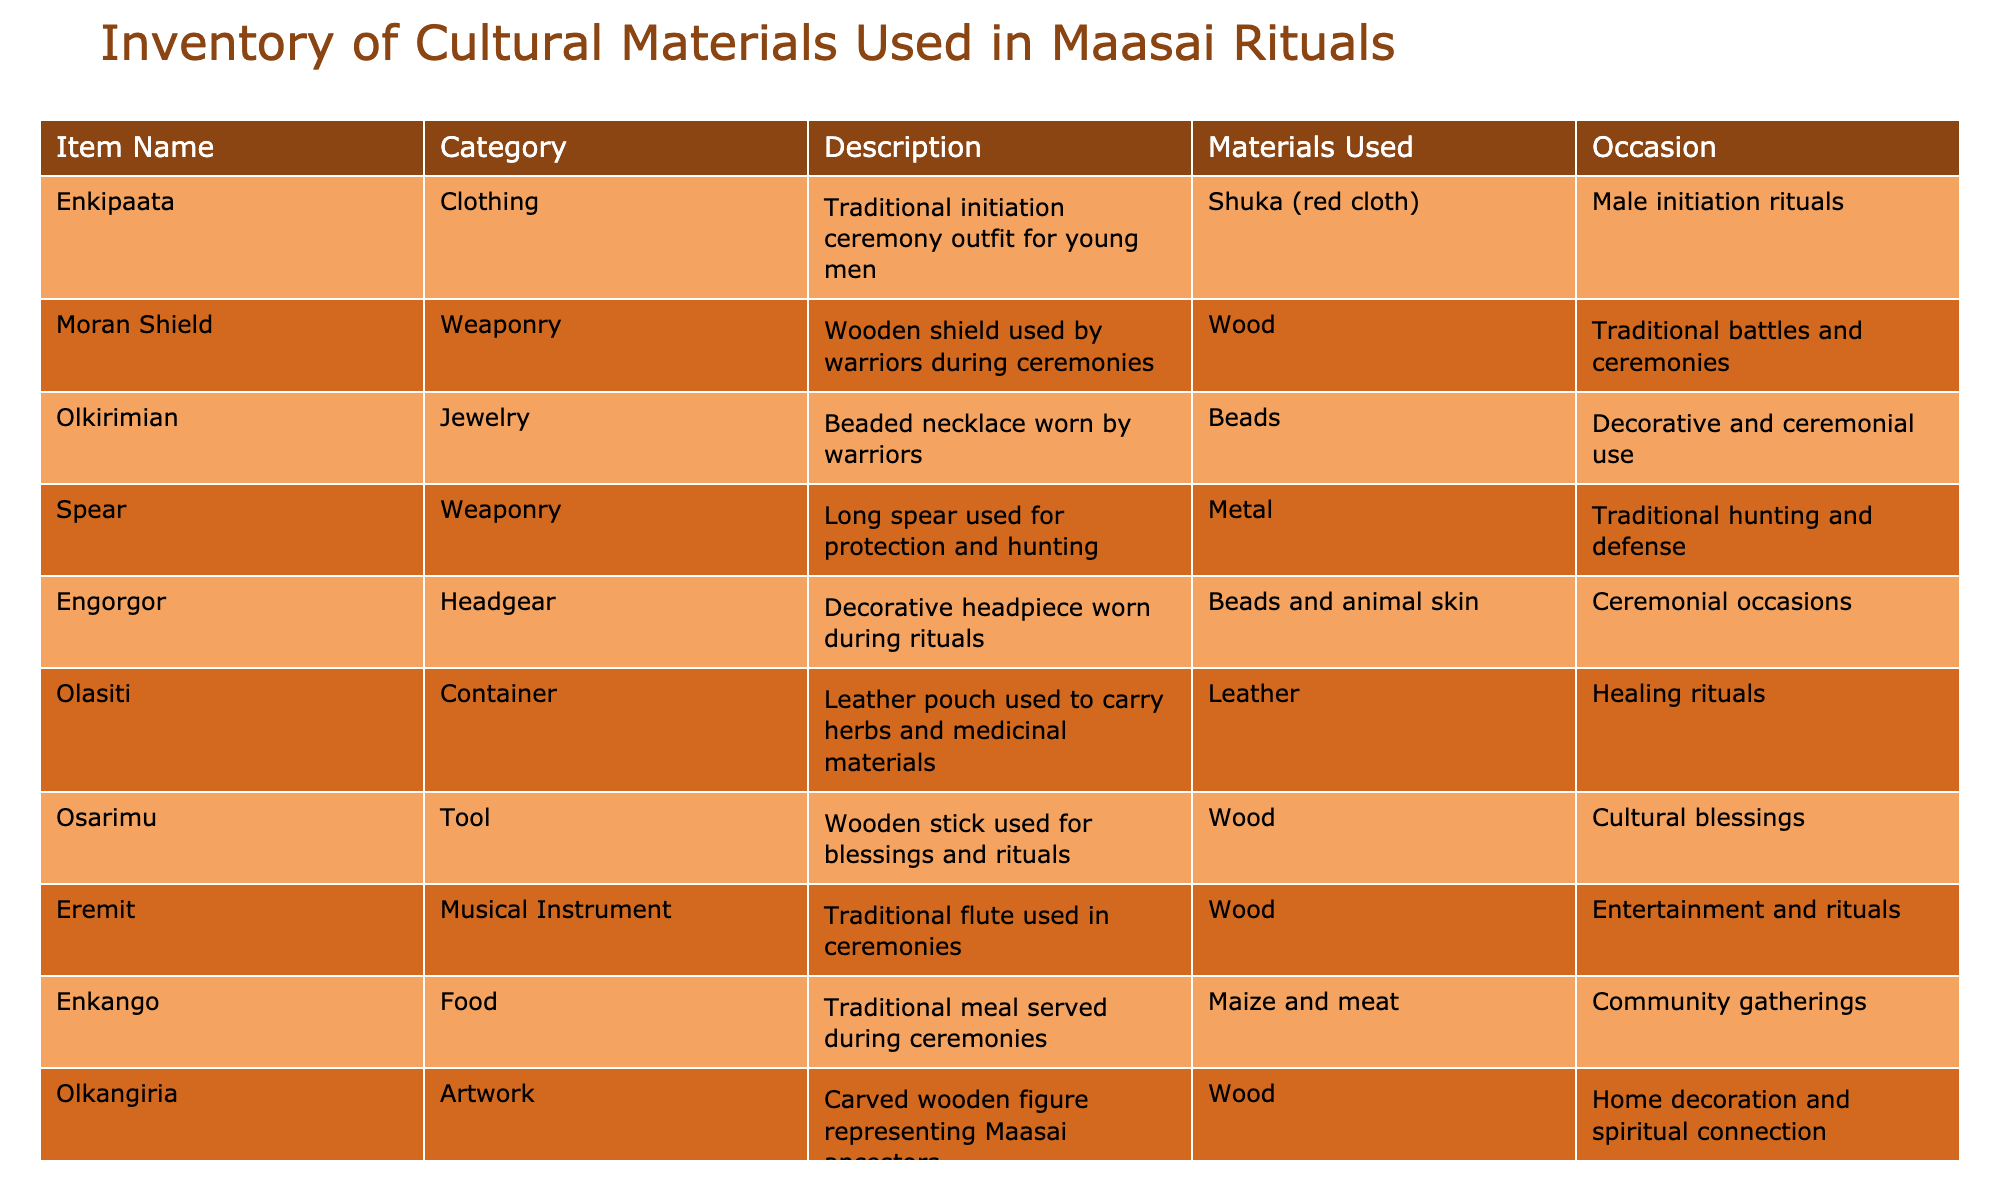What is the description of the Enkipaata? The description is found in the table in the "Description" column next to "Enkipaata." It states that it is a traditional initiation ceremony outfit for young men.
Answer: Traditional initiation ceremony outfit for young men What materials are used to make the Moran Shield? Looking at the "Materials Used" column, the shield is made of wood, as indicated next to "Moran Shield."
Answer: Wood Are there any items used for healing rituals? Yes, by scanning the "Occasion" column, we see "Healing rituals" associated with the "Olasiti," a leather pouch used to carry herbs and medicinal materials.
Answer: Yes How many distinct categories of items are listed in the inventory? We have to identify unique categories in the "Category" column. They are Clothing, Weaponry, Jewelry, Headgear, Container, Tool, Musical Instrument, Food, and Artwork, leading to a total of 9 unique categories.
Answer: 9 Which item is used for both protection and hunting? We check the "Description" column for an item that mentions both purposes. The "Spear" is described as a long spear used for protection and hunting.
Answer: Spear What is the total count of items made of beads? By reviewing the "Materials Used" column, we find two items made with beads: "Olkirimian" and "Engorgor." Thus, the total count is 2.
Answer: 2 Is there a food item served during community gatherings? Yes, the "Enkango" is listed under the "Occasion" column as served during community gatherings, confirming this fact.
Answer: Yes What are the occasions associated with the item Olkangiria? To answer this, we need to look at the "Occasion" column. "Olkangiria" is associated with home decoration and spiritual connection.
Answer: Home decoration and spiritual connection How many items are categorized as Weaponry? By scanning the "Category" column, we count the total items categorized as Weaponry, which are the "Moran Shield" and "Spear," leading to a total of 2.
Answer: 2 